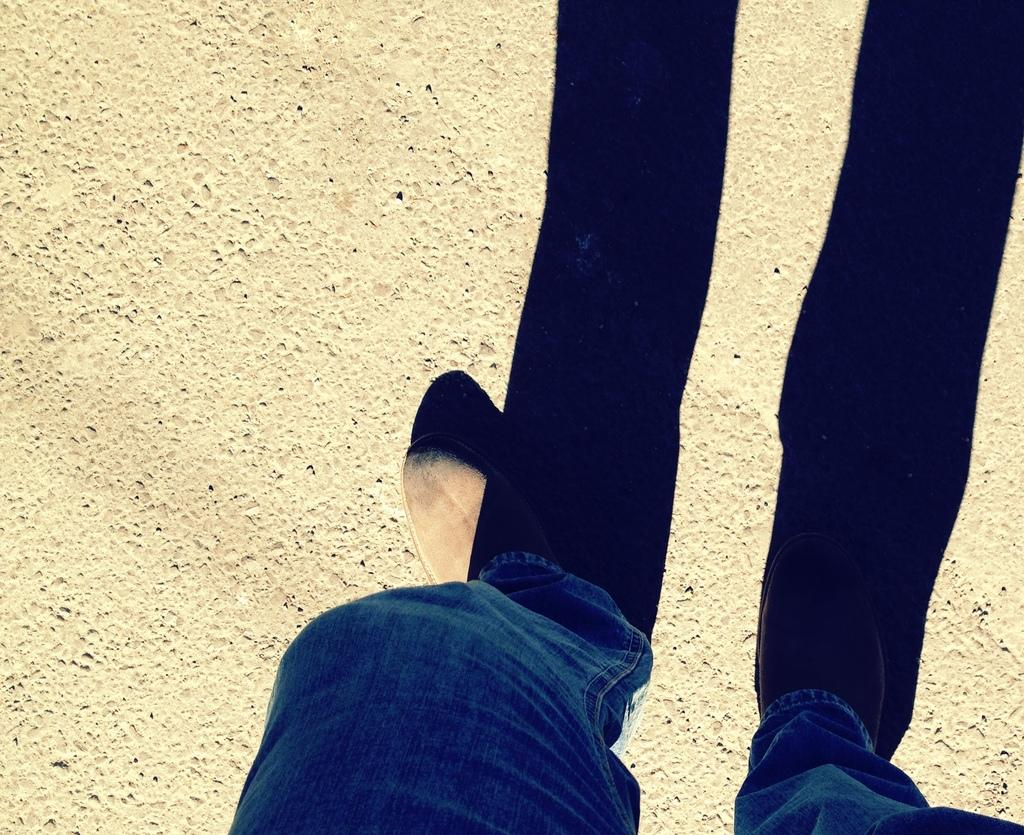What is the person in the image doing near the tree? The person is standing near a tree and talking on the phone. Can you see any ants carrying honey on the person's head in the image? There are no ants or honey present in the image; it features a person standing near a tree and talking on the phone. 